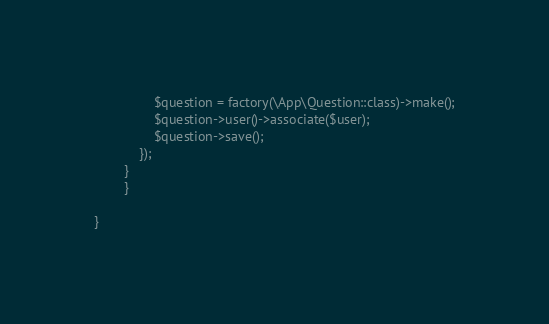Convert code to text. <code><loc_0><loc_0><loc_500><loc_500><_PHP_>                $question = factory(\App\Question::class)->make();
                $question->user()->associate($user);
                $question->save();
            });
        }
        }

}
</code> 